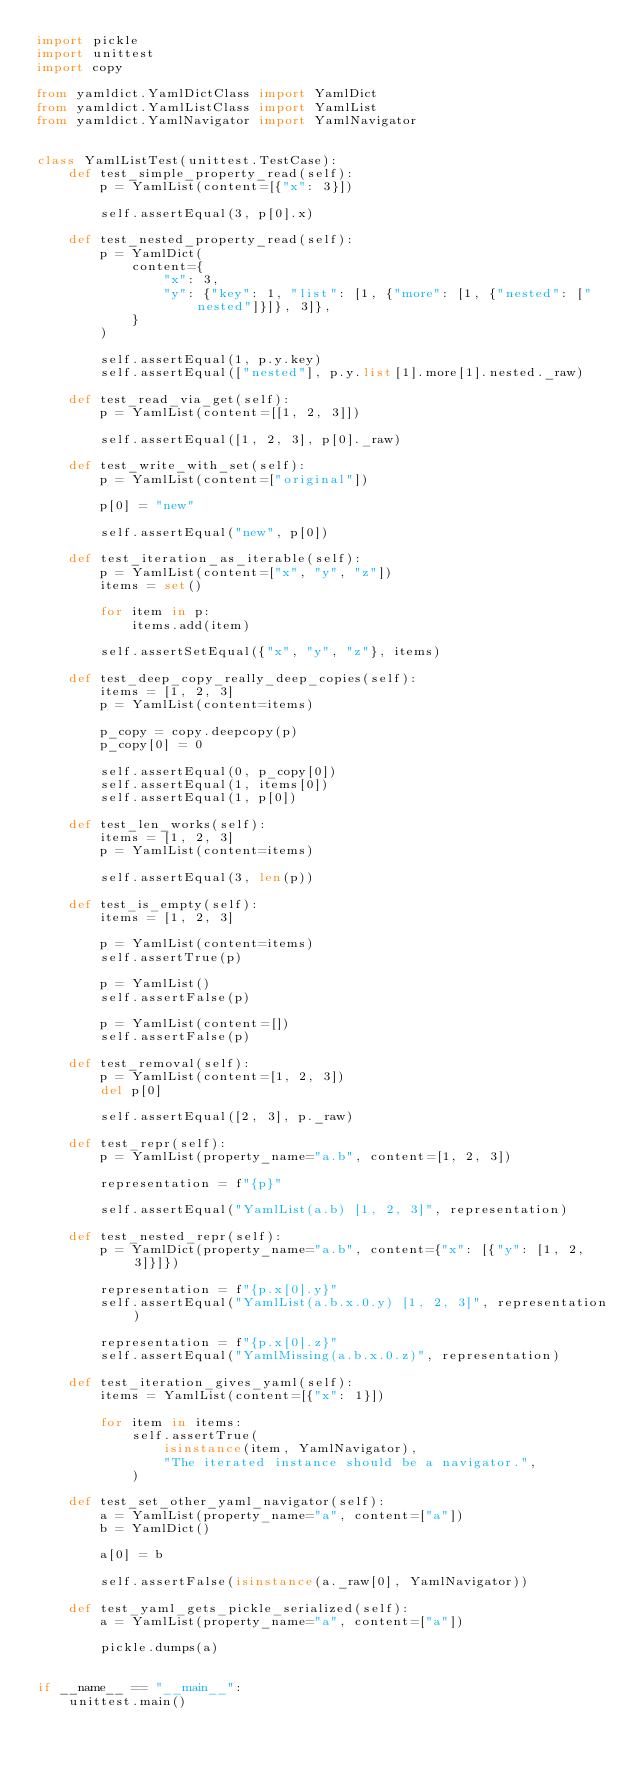Convert code to text. <code><loc_0><loc_0><loc_500><loc_500><_Python_>import pickle
import unittest
import copy

from yamldict.YamlDictClass import YamlDict
from yamldict.YamlListClass import YamlList
from yamldict.YamlNavigator import YamlNavigator


class YamlListTest(unittest.TestCase):
    def test_simple_property_read(self):
        p = YamlList(content=[{"x": 3}])

        self.assertEqual(3, p[0].x)

    def test_nested_property_read(self):
        p = YamlDict(
            content={
                "x": 3,
                "y": {"key": 1, "list": [1, {"more": [1, {"nested": ["nested"]}]}, 3]},
            }
        )

        self.assertEqual(1, p.y.key)
        self.assertEqual(["nested"], p.y.list[1].more[1].nested._raw)

    def test_read_via_get(self):
        p = YamlList(content=[[1, 2, 3]])

        self.assertEqual([1, 2, 3], p[0]._raw)

    def test_write_with_set(self):
        p = YamlList(content=["original"])

        p[0] = "new"

        self.assertEqual("new", p[0])

    def test_iteration_as_iterable(self):
        p = YamlList(content=["x", "y", "z"])
        items = set()

        for item in p:
            items.add(item)

        self.assertSetEqual({"x", "y", "z"}, items)

    def test_deep_copy_really_deep_copies(self):
        items = [1, 2, 3]
        p = YamlList(content=items)

        p_copy = copy.deepcopy(p)
        p_copy[0] = 0

        self.assertEqual(0, p_copy[0])
        self.assertEqual(1, items[0])
        self.assertEqual(1, p[0])

    def test_len_works(self):
        items = [1, 2, 3]
        p = YamlList(content=items)

        self.assertEqual(3, len(p))

    def test_is_empty(self):
        items = [1, 2, 3]

        p = YamlList(content=items)
        self.assertTrue(p)

        p = YamlList()
        self.assertFalse(p)

        p = YamlList(content=[])
        self.assertFalse(p)

    def test_removal(self):
        p = YamlList(content=[1, 2, 3])
        del p[0]

        self.assertEqual([2, 3], p._raw)

    def test_repr(self):
        p = YamlList(property_name="a.b", content=[1, 2, 3])

        representation = f"{p}"

        self.assertEqual("YamlList(a.b) [1, 2, 3]", representation)

    def test_nested_repr(self):
        p = YamlDict(property_name="a.b", content={"x": [{"y": [1, 2, 3]}]})

        representation = f"{p.x[0].y}"
        self.assertEqual("YamlList(a.b.x.0.y) [1, 2, 3]", representation)

        representation = f"{p.x[0].z}"
        self.assertEqual("YamlMissing(a.b.x.0.z)", representation)

    def test_iteration_gives_yaml(self):
        items = YamlList(content=[{"x": 1}])

        for item in items:
            self.assertTrue(
                isinstance(item, YamlNavigator),
                "The iterated instance should be a navigator.",
            )

    def test_set_other_yaml_navigator(self):
        a = YamlList(property_name="a", content=["a"])
        b = YamlDict()

        a[0] = b

        self.assertFalse(isinstance(a._raw[0], YamlNavigator))

    def test_yaml_gets_pickle_serialized(self):
        a = YamlList(property_name="a", content=["a"])

        pickle.dumps(a)


if __name__ == "__main__":
    unittest.main()
</code> 